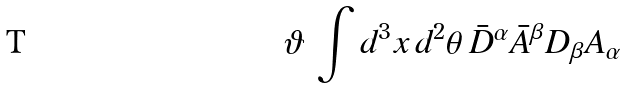Convert formula to latex. <formula><loc_0><loc_0><loc_500><loc_500>\vartheta \, \int d ^ { 3 } x \, d ^ { 2 } \theta \, \bar { D } ^ { \alpha } \bar { A } ^ { \beta } D _ { \beta } A _ { \alpha }</formula> 